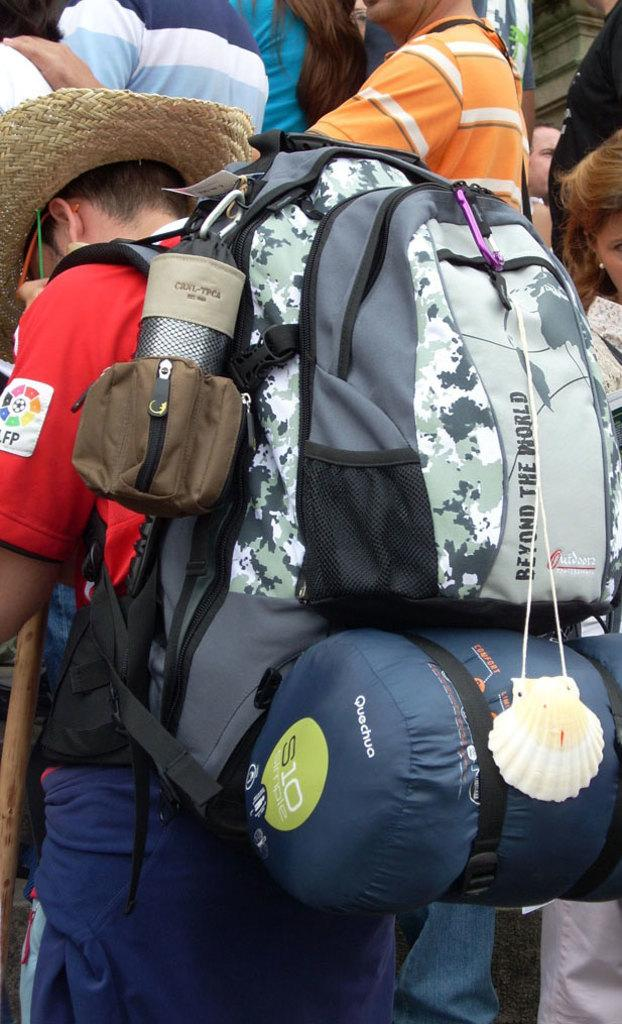What is the man in the image carrying? The man is carrying a backpack. What is the man wearing on his head? The man is wearing a hat. What color is the man's t-shirt? The man is wearing a red t-shirt. What color are the man's pants? The man is wearing blue pants. Can you describe the people in the background of the image? There are people in the background of the image, but no specific details are provided about them. What type of toothpaste is the man using in the image? There is no toothpaste present in the image; the man is wearing a hat and carrying a backpack. How many cows can be seen grazing in the background of the image? There are no cows present in the image; the background only shows people. 